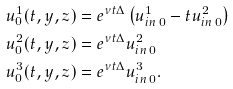Convert formula to latex. <formula><loc_0><loc_0><loc_500><loc_500>u ^ { 1 } _ { 0 } ( t , y , z ) & = e ^ { \nu t \Delta } \left ( u ^ { 1 } _ { i n \, 0 } - t u _ { i n \, 0 } ^ { 2 } \right ) \\ u ^ { 2 } _ { 0 } ( t , y , z ) & = e ^ { \nu t \Delta } u ^ { 2 } _ { i n \, 0 } \\ u ^ { 3 } _ { 0 } ( t , y , z ) & = e ^ { \nu t \Delta } u ^ { 3 } _ { i n \, 0 } .</formula> 